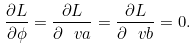Convert formula to latex. <formula><loc_0><loc_0><loc_500><loc_500>\frac { \partial L } { \partial \phi } = \frac { \partial L } { \partial \ v a } = \frac { \partial L } { \partial \ v b } = 0 .</formula> 